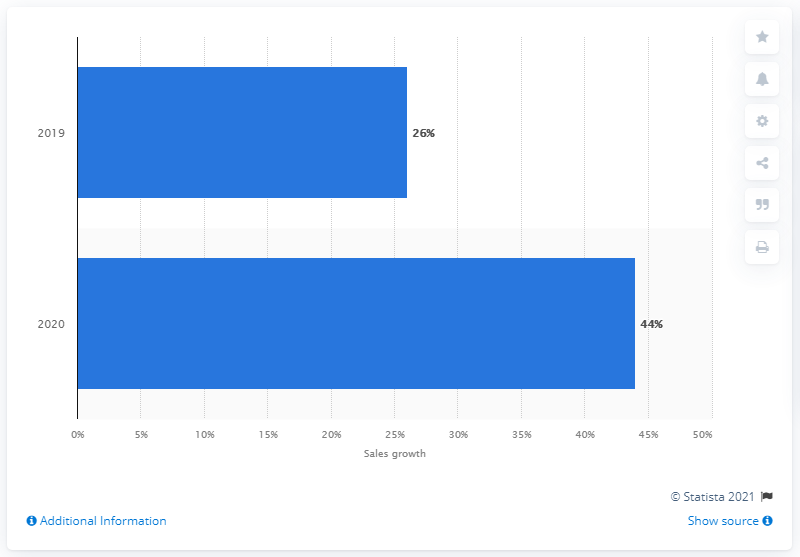Point out several critical features in this image. The growth in manga sales in the United States in 2020 was 44%. 